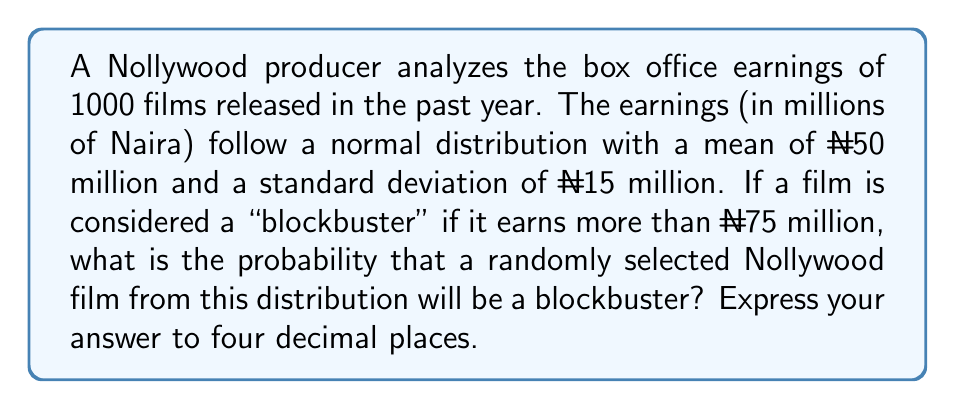Provide a solution to this math problem. Let's approach this step-by-step:

1) We're dealing with a normal distribution where:
   Mean (μ) = ₦50 million
   Standard deviation (σ) = ₦15 million

2) We want to find P(X > 75), where X is the box office earnings of a randomly selected film.

3) To use the standard normal distribution, we need to standardize our value:
   
   $$z = \frac{x - μ}{σ} = \frac{75 - 50}{15} = \frac{25}{15} ≈ 1.6667$$

4) Now we need to find P(Z > 1.6667) where Z is the standard normal variable.

5) Using a standard normal table or calculator, we can find that:
   
   P(Z < 1.6667) ≈ 0.9522

6) Since we want the probability of being greater than 1.6667:
   
   P(Z > 1.6667) = 1 - P(Z < 1.6667) = 1 - 0.9522 = 0.0478

7) Rounding to four decimal places: 0.0478
Answer: 0.0478 